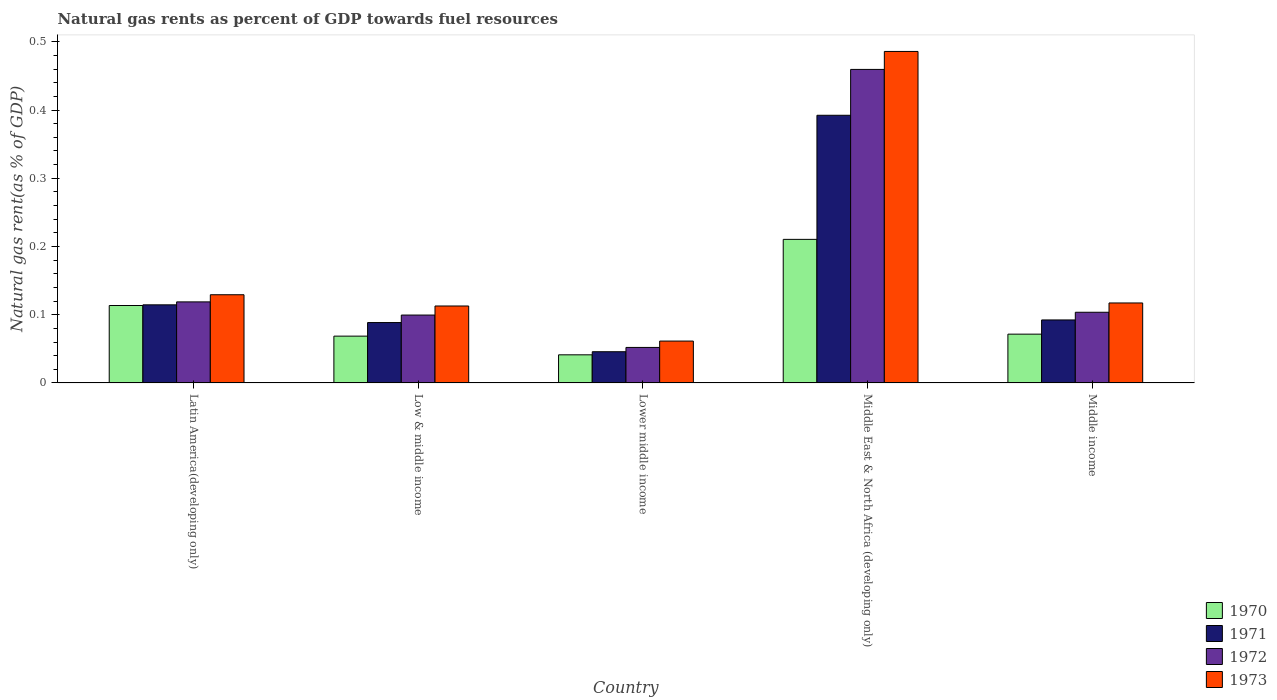How many groups of bars are there?
Your response must be concise. 5. Are the number of bars per tick equal to the number of legend labels?
Give a very brief answer. Yes. Are the number of bars on each tick of the X-axis equal?
Offer a very short reply. Yes. How many bars are there on the 4th tick from the left?
Your response must be concise. 4. What is the label of the 1st group of bars from the left?
Ensure brevity in your answer.  Latin America(developing only). What is the natural gas rent in 1972 in Lower middle income?
Provide a short and direct response. 0.05. Across all countries, what is the maximum natural gas rent in 1973?
Your response must be concise. 0.49. Across all countries, what is the minimum natural gas rent in 1973?
Keep it short and to the point. 0.06. In which country was the natural gas rent in 1972 maximum?
Offer a terse response. Middle East & North Africa (developing only). In which country was the natural gas rent in 1973 minimum?
Provide a short and direct response. Lower middle income. What is the total natural gas rent in 1971 in the graph?
Your answer should be very brief. 0.73. What is the difference between the natural gas rent in 1973 in Lower middle income and that in Middle East & North Africa (developing only)?
Provide a succinct answer. -0.42. What is the difference between the natural gas rent in 1971 in Middle income and the natural gas rent in 1973 in Middle East & North Africa (developing only)?
Give a very brief answer. -0.39. What is the average natural gas rent in 1971 per country?
Ensure brevity in your answer.  0.15. What is the difference between the natural gas rent of/in 1972 and natural gas rent of/in 1973 in Middle income?
Offer a terse response. -0.01. What is the ratio of the natural gas rent in 1973 in Low & middle income to that in Middle East & North Africa (developing only)?
Offer a terse response. 0.23. Is the natural gas rent in 1973 in Low & middle income less than that in Middle income?
Your answer should be compact. Yes. What is the difference between the highest and the second highest natural gas rent in 1971?
Your answer should be compact. 0.3. What is the difference between the highest and the lowest natural gas rent in 1970?
Give a very brief answer. 0.17. In how many countries, is the natural gas rent in 1971 greater than the average natural gas rent in 1971 taken over all countries?
Keep it short and to the point. 1. What does the 1st bar from the left in Middle East & North Africa (developing only) represents?
Keep it short and to the point. 1970. How many bars are there?
Your answer should be very brief. 20. Are all the bars in the graph horizontal?
Your response must be concise. No. How many countries are there in the graph?
Give a very brief answer. 5. Are the values on the major ticks of Y-axis written in scientific E-notation?
Provide a short and direct response. No. Does the graph contain any zero values?
Your answer should be very brief. No. Does the graph contain grids?
Make the answer very short. No. How are the legend labels stacked?
Make the answer very short. Vertical. What is the title of the graph?
Offer a very short reply. Natural gas rents as percent of GDP towards fuel resources. What is the label or title of the Y-axis?
Offer a terse response. Natural gas rent(as % of GDP). What is the Natural gas rent(as % of GDP) in 1970 in Latin America(developing only)?
Ensure brevity in your answer.  0.11. What is the Natural gas rent(as % of GDP) of 1971 in Latin America(developing only)?
Ensure brevity in your answer.  0.11. What is the Natural gas rent(as % of GDP) of 1972 in Latin America(developing only)?
Your response must be concise. 0.12. What is the Natural gas rent(as % of GDP) of 1973 in Latin America(developing only)?
Your answer should be very brief. 0.13. What is the Natural gas rent(as % of GDP) of 1970 in Low & middle income?
Give a very brief answer. 0.07. What is the Natural gas rent(as % of GDP) of 1971 in Low & middle income?
Give a very brief answer. 0.09. What is the Natural gas rent(as % of GDP) of 1972 in Low & middle income?
Your response must be concise. 0.1. What is the Natural gas rent(as % of GDP) of 1973 in Low & middle income?
Make the answer very short. 0.11. What is the Natural gas rent(as % of GDP) in 1970 in Lower middle income?
Give a very brief answer. 0.04. What is the Natural gas rent(as % of GDP) of 1971 in Lower middle income?
Your answer should be compact. 0.05. What is the Natural gas rent(as % of GDP) in 1972 in Lower middle income?
Make the answer very short. 0.05. What is the Natural gas rent(as % of GDP) in 1973 in Lower middle income?
Your response must be concise. 0.06. What is the Natural gas rent(as % of GDP) in 1970 in Middle East & North Africa (developing only)?
Ensure brevity in your answer.  0.21. What is the Natural gas rent(as % of GDP) in 1971 in Middle East & North Africa (developing only)?
Provide a succinct answer. 0.39. What is the Natural gas rent(as % of GDP) in 1972 in Middle East & North Africa (developing only)?
Give a very brief answer. 0.46. What is the Natural gas rent(as % of GDP) of 1973 in Middle East & North Africa (developing only)?
Give a very brief answer. 0.49. What is the Natural gas rent(as % of GDP) of 1970 in Middle income?
Give a very brief answer. 0.07. What is the Natural gas rent(as % of GDP) in 1971 in Middle income?
Your response must be concise. 0.09. What is the Natural gas rent(as % of GDP) in 1972 in Middle income?
Your answer should be very brief. 0.1. What is the Natural gas rent(as % of GDP) of 1973 in Middle income?
Provide a succinct answer. 0.12. Across all countries, what is the maximum Natural gas rent(as % of GDP) in 1970?
Your answer should be very brief. 0.21. Across all countries, what is the maximum Natural gas rent(as % of GDP) in 1971?
Make the answer very short. 0.39. Across all countries, what is the maximum Natural gas rent(as % of GDP) in 1972?
Offer a terse response. 0.46. Across all countries, what is the maximum Natural gas rent(as % of GDP) in 1973?
Give a very brief answer. 0.49. Across all countries, what is the minimum Natural gas rent(as % of GDP) in 1970?
Ensure brevity in your answer.  0.04. Across all countries, what is the minimum Natural gas rent(as % of GDP) in 1971?
Ensure brevity in your answer.  0.05. Across all countries, what is the minimum Natural gas rent(as % of GDP) in 1972?
Your answer should be very brief. 0.05. Across all countries, what is the minimum Natural gas rent(as % of GDP) of 1973?
Make the answer very short. 0.06. What is the total Natural gas rent(as % of GDP) in 1970 in the graph?
Provide a succinct answer. 0.51. What is the total Natural gas rent(as % of GDP) of 1971 in the graph?
Your answer should be very brief. 0.73. What is the total Natural gas rent(as % of GDP) of 1972 in the graph?
Your answer should be compact. 0.83. What is the total Natural gas rent(as % of GDP) of 1973 in the graph?
Your answer should be very brief. 0.91. What is the difference between the Natural gas rent(as % of GDP) of 1970 in Latin America(developing only) and that in Low & middle income?
Your response must be concise. 0.04. What is the difference between the Natural gas rent(as % of GDP) in 1971 in Latin America(developing only) and that in Low & middle income?
Offer a terse response. 0.03. What is the difference between the Natural gas rent(as % of GDP) of 1972 in Latin America(developing only) and that in Low & middle income?
Provide a succinct answer. 0.02. What is the difference between the Natural gas rent(as % of GDP) in 1973 in Latin America(developing only) and that in Low & middle income?
Make the answer very short. 0.02. What is the difference between the Natural gas rent(as % of GDP) of 1970 in Latin America(developing only) and that in Lower middle income?
Give a very brief answer. 0.07. What is the difference between the Natural gas rent(as % of GDP) of 1971 in Latin America(developing only) and that in Lower middle income?
Keep it short and to the point. 0.07. What is the difference between the Natural gas rent(as % of GDP) in 1972 in Latin America(developing only) and that in Lower middle income?
Provide a short and direct response. 0.07. What is the difference between the Natural gas rent(as % of GDP) of 1973 in Latin America(developing only) and that in Lower middle income?
Provide a succinct answer. 0.07. What is the difference between the Natural gas rent(as % of GDP) of 1970 in Latin America(developing only) and that in Middle East & North Africa (developing only)?
Offer a very short reply. -0.1. What is the difference between the Natural gas rent(as % of GDP) of 1971 in Latin America(developing only) and that in Middle East & North Africa (developing only)?
Your answer should be very brief. -0.28. What is the difference between the Natural gas rent(as % of GDP) in 1972 in Latin America(developing only) and that in Middle East & North Africa (developing only)?
Keep it short and to the point. -0.34. What is the difference between the Natural gas rent(as % of GDP) in 1973 in Latin America(developing only) and that in Middle East & North Africa (developing only)?
Give a very brief answer. -0.36. What is the difference between the Natural gas rent(as % of GDP) of 1970 in Latin America(developing only) and that in Middle income?
Offer a very short reply. 0.04. What is the difference between the Natural gas rent(as % of GDP) of 1971 in Latin America(developing only) and that in Middle income?
Keep it short and to the point. 0.02. What is the difference between the Natural gas rent(as % of GDP) of 1972 in Latin America(developing only) and that in Middle income?
Offer a terse response. 0.02. What is the difference between the Natural gas rent(as % of GDP) of 1973 in Latin America(developing only) and that in Middle income?
Provide a short and direct response. 0.01. What is the difference between the Natural gas rent(as % of GDP) of 1970 in Low & middle income and that in Lower middle income?
Ensure brevity in your answer.  0.03. What is the difference between the Natural gas rent(as % of GDP) in 1971 in Low & middle income and that in Lower middle income?
Give a very brief answer. 0.04. What is the difference between the Natural gas rent(as % of GDP) of 1972 in Low & middle income and that in Lower middle income?
Your response must be concise. 0.05. What is the difference between the Natural gas rent(as % of GDP) in 1973 in Low & middle income and that in Lower middle income?
Keep it short and to the point. 0.05. What is the difference between the Natural gas rent(as % of GDP) in 1970 in Low & middle income and that in Middle East & North Africa (developing only)?
Ensure brevity in your answer.  -0.14. What is the difference between the Natural gas rent(as % of GDP) of 1971 in Low & middle income and that in Middle East & North Africa (developing only)?
Provide a succinct answer. -0.3. What is the difference between the Natural gas rent(as % of GDP) in 1972 in Low & middle income and that in Middle East & North Africa (developing only)?
Your answer should be compact. -0.36. What is the difference between the Natural gas rent(as % of GDP) in 1973 in Low & middle income and that in Middle East & North Africa (developing only)?
Offer a terse response. -0.37. What is the difference between the Natural gas rent(as % of GDP) of 1970 in Low & middle income and that in Middle income?
Offer a terse response. -0. What is the difference between the Natural gas rent(as % of GDP) of 1971 in Low & middle income and that in Middle income?
Provide a succinct answer. -0. What is the difference between the Natural gas rent(as % of GDP) in 1972 in Low & middle income and that in Middle income?
Offer a very short reply. -0. What is the difference between the Natural gas rent(as % of GDP) in 1973 in Low & middle income and that in Middle income?
Ensure brevity in your answer.  -0. What is the difference between the Natural gas rent(as % of GDP) in 1970 in Lower middle income and that in Middle East & North Africa (developing only)?
Your answer should be very brief. -0.17. What is the difference between the Natural gas rent(as % of GDP) in 1971 in Lower middle income and that in Middle East & North Africa (developing only)?
Keep it short and to the point. -0.35. What is the difference between the Natural gas rent(as % of GDP) of 1972 in Lower middle income and that in Middle East & North Africa (developing only)?
Provide a succinct answer. -0.41. What is the difference between the Natural gas rent(as % of GDP) of 1973 in Lower middle income and that in Middle East & North Africa (developing only)?
Your answer should be very brief. -0.42. What is the difference between the Natural gas rent(as % of GDP) in 1970 in Lower middle income and that in Middle income?
Keep it short and to the point. -0.03. What is the difference between the Natural gas rent(as % of GDP) of 1971 in Lower middle income and that in Middle income?
Offer a terse response. -0.05. What is the difference between the Natural gas rent(as % of GDP) in 1972 in Lower middle income and that in Middle income?
Ensure brevity in your answer.  -0.05. What is the difference between the Natural gas rent(as % of GDP) in 1973 in Lower middle income and that in Middle income?
Keep it short and to the point. -0.06. What is the difference between the Natural gas rent(as % of GDP) in 1970 in Middle East & North Africa (developing only) and that in Middle income?
Provide a short and direct response. 0.14. What is the difference between the Natural gas rent(as % of GDP) in 1971 in Middle East & North Africa (developing only) and that in Middle income?
Provide a short and direct response. 0.3. What is the difference between the Natural gas rent(as % of GDP) in 1972 in Middle East & North Africa (developing only) and that in Middle income?
Make the answer very short. 0.36. What is the difference between the Natural gas rent(as % of GDP) of 1973 in Middle East & North Africa (developing only) and that in Middle income?
Your answer should be compact. 0.37. What is the difference between the Natural gas rent(as % of GDP) in 1970 in Latin America(developing only) and the Natural gas rent(as % of GDP) in 1971 in Low & middle income?
Provide a short and direct response. 0.03. What is the difference between the Natural gas rent(as % of GDP) in 1970 in Latin America(developing only) and the Natural gas rent(as % of GDP) in 1972 in Low & middle income?
Provide a short and direct response. 0.01. What is the difference between the Natural gas rent(as % of GDP) of 1970 in Latin America(developing only) and the Natural gas rent(as % of GDP) of 1973 in Low & middle income?
Your response must be concise. 0. What is the difference between the Natural gas rent(as % of GDP) in 1971 in Latin America(developing only) and the Natural gas rent(as % of GDP) in 1972 in Low & middle income?
Your response must be concise. 0.01. What is the difference between the Natural gas rent(as % of GDP) of 1971 in Latin America(developing only) and the Natural gas rent(as % of GDP) of 1973 in Low & middle income?
Make the answer very short. 0. What is the difference between the Natural gas rent(as % of GDP) in 1972 in Latin America(developing only) and the Natural gas rent(as % of GDP) in 1973 in Low & middle income?
Your response must be concise. 0.01. What is the difference between the Natural gas rent(as % of GDP) in 1970 in Latin America(developing only) and the Natural gas rent(as % of GDP) in 1971 in Lower middle income?
Offer a very short reply. 0.07. What is the difference between the Natural gas rent(as % of GDP) in 1970 in Latin America(developing only) and the Natural gas rent(as % of GDP) in 1972 in Lower middle income?
Keep it short and to the point. 0.06. What is the difference between the Natural gas rent(as % of GDP) in 1970 in Latin America(developing only) and the Natural gas rent(as % of GDP) in 1973 in Lower middle income?
Offer a terse response. 0.05. What is the difference between the Natural gas rent(as % of GDP) in 1971 in Latin America(developing only) and the Natural gas rent(as % of GDP) in 1972 in Lower middle income?
Your answer should be very brief. 0.06. What is the difference between the Natural gas rent(as % of GDP) of 1971 in Latin America(developing only) and the Natural gas rent(as % of GDP) of 1973 in Lower middle income?
Your answer should be compact. 0.05. What is the difference between the Natural gas rent(as % of GDP) of 1972 in Latin America(developing only) and the Natural gas rent(as % of GDP) of 1973 in Lower middle income?
Ensure brevity in your answer.  0.06. What is the difference between the Natural gas rent(as % of GDP) in 1970 in Latin America(developing only) and the Natural gas rent(as % of GDP) in 1971 in Middle East & North Africa (developing only)?
Ensure brevity in your answer.  -0.28. What is the difference between the Natural gas rent(as % of GDP) of 1970 in Latin America(developing only) and the Natural gas rent(as % of GDP) of 1972 in Middle East & North Africa (developing only)?
Ensure brevity in your answer.  -0.35. What is the difference between the Natural gas rent(as % of GDP) in 1970 in Latin America(developing only) and the Natural gas rent(as % of GDP) in 1973 in Middle East & North Africa (developing only)?
Your response must be concise. -0.37. What is the difference between the Natural gas rent(as % of GDP) of 1971 in Latin America(developing only) and the Natural gas rent(as % of GDP) of 1972 in Middle East & North Africa (developing only)?
Your response must be concise. -0.35. What is the difference between the Natural gas rent(as % of GDP) of 1971 in Latin America(developing only) and the Natural gas rent(as % of GDP) of 1973 in Middle East & North Africa (developing only)?
Offer a very short reply. -0.37. What is the difference between the Natural gas rent(as % of GDP) of 1972 in Latin America(developing only) and the Natural gas rent(as % of GDP) of 1973 in Middle East & North Africa (developing only)?
Provide a short and direct response. -0.37. What is the difference between the Natural gas rent(as % of GDP) of 1970 in Latin America(developing only) and the Natural gas rent(as % of GDP) of 1971 in Middle income?
Ensure brevity in your answer.  0.02. What is the difference between the Natural gas rent(as % of GDP) of 1970 in Latin America(developing only) and the Natural gas rent(as % of GDP) of 1972 in Middle income?
Offer a very short reply. 0.01. What is the difference between the Natural gas rent(as % of GDP) of 1970 in Latin America(developing only) and the Natural gas rent(as % of GDP) of 1973 in Middle income?
Offer a terse response. -0. What is the difference between the Natural gas rent(as % of GDP) of 1971 in Latin America(developing only) and the Natural gas rent(as % of GDP) of 1972 in Middle income?
Offer a terse response. 0.01. What is the difference between the Natural gas rent(as % of GDP) in 1971 in Latin America(developing only) and the Natural gas rent(as % of GDP) in 1973 in Middle income?
Give a very brief answer. -0. What is the difference between the Natural gas rent(as % of GDP) of 1972 in Latin America(developing only) and the Natural gas rent(as % of GDP) of 1973 in Middle income?
Provide a succinct answer. 0. What is the difference between the Natural gas rent(as % of GDP) in 1970 in Low & middle income and the Natural gas rent(as % of GDP) in 1971 in Lower middle income?
Your answer should be compact. 0.02. What is the difference between the Natural gas rent(as % of GDP) of 1970 in Low & middle income and the Natural gas rent(as % of GDP) of 1972 in Lower middle income?
Provide a short and direct response. 0.02. What is the difference between the Natural gas rent(as % of GDP) in 1970 in Low & middle income and the Natural gas rent(as % of GDP) in 1973 in Lower middle income?
Make the answer very short. 0.01. What is the difference between the Natural gas rent(as % of GDP) in 1971 in Low & middle income and the Natural gas rent(as % of GDP) in 1972 in Lower middle income?
Keep it short and to the point. 0.04. What is the difference between the Natural gas rent(as % of GDP) in 1971 in Low & middle income and the Natural gas rent(as % of GDP) in 1973 in Lower middle income?
Ensure brevity in your answer.  0.03. What is the difference between the Natural gas rent(as % of GDP) in 1972 in Low & middle income and the Natural gas rent(as % of GDP) in 1973 in Lower middle income?
Provide a short and direct response. 0.04. What is the difference between the Natural gas rent(as % of GDP) in 1970 in Low & middle income and the Natural gas rent(as % of GDP) in 1971 in Middle East & North Africa (developing only)?
Make the answer very short. -0.32. What is the difference between the Natural gas rent(as % of GDP) of 1970 in Low & middle income and the Natural gas rent(as % of GDP) of 1972 in Middle East & North Africa (developing only)?
Your response must be concise. -0.39. What is the difference between the Natural gas rent(as % of GDP) of 1970 in Low & middle income and the Natural gas rent(as % of GDP) of 1973 in Middle East & North Africa (developing only)?
Give a very brief answer. -0.42. What is the difference between the Natural gas rent(as % of GDP) of 1971 in Low & middle income and the Natural gas rent(as % of GDP) of 1972 in Middle East & North Africa (developing only)?
Provide a short and direct response. -0.37. What is the difference between the Natural gas rent(as % of GDP) of 1971 in Low & middle income and the Natural gas rent(as % of GDP) of 1973 in Middle East & North Africa (developing only)?
Offer a terse response. -0.4. What is the difference between the Natural gas rent(as % of GDP) of 1972 in Low & middle income and the Natural gas rent(as % of GDP) of 1973 in Middle East & North Africa (developing only)?
Ensure brevity in your answer.  -0.39. What is the difference between the Natural gas rent(as % of GDP) of 1970 in Low & middle income and the Natural gas rent(as % of GDP) of 1971 in Middle income?
Keep it short and to the point. -0.02. What is the difference between the Natural gas rent(as % of GDP) of 1970 in Low & middle income and the Natural gas rent(as % of GDP) of 1972 in Middle income?
Provide a short and direct response. -0.04. What is the difference between the Natural gas rent(as % of GDP) of 1970 in Low & middle income and the Natural gas rent(as % of GDP) of 1973 in Middle income?
Offer a terse response. -0.05. What is the difference between the Natural gas rent(as % of GDP) of 1971 in Low & middle income and the Natural gas rent(as % of GDP) of 1972 in Middle income?
Your answer should be compact. -0.02. What is the difference between the Natural gas rent(as % of GDP) in 1971 in Low & middle income and the Natural gas rent(as % of GDP) in 1973 in Middle income?
Offer a terse response. -0.03. What is the difference between the Natural gas rent(as % of GDP) of 1972 in Low & middle income and the Natural gas rent(as % of GDP) of 1973 in Middle income?
Provide a succinct answer. -0.02. What is the difference between the Natural gas rent(as % of GDP) of 1970 in Lower middle income and the Natural gas rent(as % of GDP) of 1971 in Middle East & North Africa (developing only)?
Offer a very short reply. -0.35. What is the difference between the Natural gas rent(as % of GDP) of 1970 in Lower middle income and the Natural gas rent(as % of GDP) of 1972 in Middle East & North Africa (developing only)?
Provide a short and direct response. -0.42. What is the difference between the Natural gas rent(as % of GDP) of 1970 in Lower middle income and the Natural gas rent(as % of GDP) of 1973 in Middle East & North Africa (developing only)?
Offer a very short reply. -0.44. What is the difference between the Natural gas rent(as % of GDP) in 1971 in Lower middle income and the Natural gas rent(as % of GDP) in 1972 in Middle East & North Africa (developing only)?
Offer a very short reply. -0.41. What is the difference between the Natural gas rent(as % of GDP) of 1971 in Lower middle income and the Natural gas rent(as % of GDP) of 1973 in Middle East & North Africa (developing only)?
Provide a succinct answer. -0.44. What is the difference between the Natural gas rent(as % of GDP) in 1972 in Lower middle income and the Natural gas rent(as % of GDP) in 1973 in Middle East & North Africa (developing only)?
Your answer should be compact. -0.43. What is the difference between the Natural gas rent(as % of GDP) of 1970 in Lower middle income and the Natural gas rent(as % of GDP) of 1971 in Middle income?
Offer a very short reply. -0.05. What is the difference between the Natural gas rent(as % of GDP) in 1970 in Lower middle income and the Natural gas rent(as % of GDP) in 1972 in Middle income?
Provide a succinct answer. -0.06. What is the difference between the Natural gas rent(as % of GDP) in 1970 in Lower middle income and the Natural gas rent(as % of GDP) in 1973 in Middle income?
Make the answer very short. -0.08. What is the difference between the Natural gas rent(as % of GDP) in 1971 in Lower middle income and the Natural gas rent(as % of GDP) in 1972 in Middle income?
Provide a succinct answer. -0.06. What is the difference between the Natural gas rent(as % of GDP) in 1971 in Lower middle income and the Natural gas rent(as % of GDP) in 1973 in Middle income?
Keep it short and to the point. -0.07. What is the difference between the Natural gas rent(as % of GDP) of 1972 in Lower middle income and the Natural gas rent(as % of GDP) of 1973 in Middle income?
Your response must be concise. -0.07. What is the difference between the Natural gas rent(as % of GDP) in 1970 in Middle East & North Africa (developing only) and the Natural gas rent(as % of GDP) in 1971 in Middle income?
Offer a very short reply. 0.12. What is the difference between the Natural gas rent(as % of GDP) of 1970 in Middle East & North Africa (developing only) and the Natural gas rent(as % of GDP) of 1972 in Middle income?
Provide a succinct answer. 0.11. What is the difference between the Natural gas rent(as % of GDP) in 1970 in Middle East & North Africa (developing only) and the Natural gas rent(as % of GDP) in 1973 in Middle income?
Give a very brief answer. 0.09. What is the difference between the Natural gas rent(as % of GDP) of 1971 in Middle East & North Africa (developing only) and the Natural gas rent(as % of GDP) of 1972 in Middle income?
Keep it short and to the point. 0.29. What is the difference between the Natural gas rent(as % of GDP) in 1971 in Middle East & North Africa (developing only) and the Natural gas rent(as % of GDP) in 1973 in Middle income?
Offer a very short reply. 0.28. What is the difference between the Natural gas rent(as % of GDP) of 1972 in Middle East & North Africa (developing only) and the Natural gas rent(as % of GDP) of 1973 in Middle income?
Your answer should be very brief. 0.34. What is the average Natural gas rent(as % of GDP) in 1970 per country?
Your answer should be compact. 0.1. What is the average Natural gas rent(as % of GDP) of 1971 per country?
Provide a succinct answer. 0.15. What is the average Natural gas rent(as % of GDP) of 1973 per country?
Your answer should be compact. 0.18. What is the difference between the Natural gas rent(as % of GDP) in 1970 and Natural gas rent(as % of GDP) in 1971 in Latin America(developing only)?
Offer a terse response. -0. What is the difference between the Natural gas rent(as % of GDP) of 1970 and Natural gas rent(as % of GDP) of 1972 in Latin America(developing only)?
Your answer should be very brief. -0.01. What is the difference between the Natural gas rent(as % of GDP) of 1970 and Natural gas rent(as % of GDP) of 1973 in Latin America(developing only)?
Make the answer very short. -0.02. What is the difference between the Natural gas rent(as % of GDP) in 1971 and Natural gas rent(as % of GDP) in 1972 in Latin America(developing only)?
Offer a terse response. -0. What is the difference between the Natural gas rent(as % of GDP) in 1971 and Natural gas rent(as % of GDP) in 1973 in Latin America(developing only)?
Provide a short and direct response. -0.01. What is the difference between the Natural gas rent(as % of GDP) in 1972 and Natural gas rent(as % of GDP) in 1973 in Latin America(developing only)?
Make the answer very short. -0.01. What is the difference between the Natural gas rent(as % of GDP) of 1970 and Natural gas rent(as % of GDP) of 1971 in Low & middle income?
Provide a short and direct response. -0.02. What is the difference between the Natural gas rent(as % of GDP) in 1970 and Natural gas rent(as % of GDP) in 1972 in Low & middle income?
Provide a short and direct response. -0.03. What is the difference between the Natural gas rent(as % of GDP) of 1970 and Natural gas rent(as % of GDP) of 1973 in Low & middle income?
Your answer should be compact. -0.04. What is the difference between the Natural gas rent(as % of GDP) of 1971 and Natural gas rent(as % of GDP) of 1972 in Low & middle income?
Your response must be concise. -0.01. What is the difference between the Natural gas rent(as % of GDP) of 1971 and Natural gas rent(as % of GDP) of 1973 in Low & middle income?
Give a very brief answer. -0.02. What is the difference between the Natural gas rent(as % of GDP) in 1972 and Natural gas rent(as % of GDP) in 1973 in Low & middle income?
Ensure brevity in your answer.  -0.01. What is the difference between the Natural gas rent(as % of GDP) of 1970 and Natural gas rent(as % of GDP) of 1971 in Lower middle income?
Provide a succinct answer. -0. What is the difference between the Natural gas rent(as % of GDP) in 1970 and Natural gas rent(as % of GDP) in 1972 in Lower middle income?
Your response must be concise. -0.01. What is the difference between the Natural gas rent(as % of GDP) in 1970 and Natural gas rent(as % of GDP) in 1973 in Lower middle income?
Keep it short and to the point. -0.02. What is the difference between the Natural gas rent(as % of GDP) in 1971 and Natural gas rent(as % of GDP) in 1972 in Lower middle income?
Your answer should be very brief. -0.01. What is the difference between the Natural gas rent(as % of GDP) in 1971 and Natural gas rent(as % of GDP) in 1973 in Lower middle income?
Offer a very short reply. -0.02. What is the difference between the Natural gas rent(as % of GDP) of 1972 and Natural gas rent(as % of GDP) of 1973 in Lower middle income?
Keep it short and to the point. -0.01. What is the difference between the Natural gas rent(as % of GDP) in 1970 and Natural gas rent(as % of GDP) in 1971 in Middle East & North Africa (developing only)?
Your answer should be compact. -0.18. What is the difference between the Natural gas rent(as % of GDP) of 1970 and Natural gas rent(as % of GDP) of 1972 in Middle East & North Africa (developing only)?
Give a very brief answer. -0.25. What is the difference between the Natural gas rent(as % of GDP) of 1970 and Natural gas rent(as % of GDP) of 1973 in Middle East & North Africa (developing only)?
Offer a terse response. -0.28. What is the difference between the Natural gas rent(as % of GDP) of 1971 and Natural gas rent(as % of GDP) of 1972 in Middle East & North Africa (developing only)?
Ensure brevity in your answer.  -0.07. What is the difference between the Natural gas rent(as % of GDP) of 1971 and Natural gas rent(as % of GDP) of 1973 in Middle East & North Africa (developing only)?
Make the answer very short. -0.09. What is the difference between the Natural gas rent(as % of GDP) of 1972 and Natural gas rent(as % of GDP) of 1973 in Middle East & North Africa (developing only)?
Your answer should be very brief. -0.03. What is the difference between the Natural gas rent(as % of GDP) in 1970 and Natural gas rent(as % of GDP) in 1971 in Middle income?
Your response must be concise. -0.02. What is the difference between the Natural gas rent(as % of GDP) of 1970 and Natural gas rent(as % of GDP) of 1972 in Middle income?
Ensure brevity in your answer.  -0.03. What is the difference between the Natural gas rent(as % of GDP) of 1970 and Natural gas rent(as % of GDP) of 1973 in Middle income?
Offer a terse response. -0.05. What is the difference between the Natural gas rent(as % of GDP) of 1971 and Natural gas rent(as % of GDP) of 1972 in Middle income?
Make the answer very short. -0.01. What is the difference between the Natural gas rent(as % of GDP) of 1971 and Natural gas rent(as % of GDP) of 1973 in Middle income?
Your answer should be compact. -0.02. What is the difference between the Natural gas rent(as % of GDP) of 1972 and Natural gas rent(as % of GDP) of 1973 in Middle income?
Make the answer very short. -0.01. What is the ratio of the Natural gas rent(as % of GDP) of 1970 in Latin America(developing only) to that in Low & middle income?
Your answer should be compact. 1.65. What is the ratio of the Natural gas rent(as % of GDP) of 1971 in Latin America(developing only) to that in Low & middle income?
Offer a very short reply. 1.29. What is the ratio of the Natural gas rent(as % of GDP) in 1972 in Latin America(developing only) to that in Low & middle income?
Provide a succinct answer. 1.19. What is the ratio of the Natural gas rent(as % of GDP) of 1973 in Latin America(developing only) to that in Low & middle income?
Your response must be concise. 1.15. What is the ratio of the Natural gas rent(as % of GDP) of 1970 in Latin America(developing only) to that in Lower middle income?
Ensure brevity in your answer.  2.75. What is the ratio of the Natural gas rent(as % of GDP) in 1971 in Latin America(developing only) to that in Lower middle income?
Keep it short and to the point. 2.5. What is the ratio of the Natural gas rent(as % of GDP) in 1972 in Latin America(developing only) to that in Lower middle income?
Make the answer very short. 2.28. What is the ratio of the Natural gas rent(as % of GDP) in 1973 in Latin America(developing only) to that in Lower middle income?
Offer a very short reply. 2.11. What is the ratio of the Natural gas rent(as % of GDP) of 1970 in Latin America(developing only) to that in Middle East & North Africa (developing only)?
Your answer should be compact. 0.54. What is the ratio of the Natural gas rent(as % of GDP) in 1971 in Latin America(developing only) to that in Middle East & North Africa (developing only)?
Provide a succinct answer. 0.29. What is the ratio of the Natural gas rent(as % of GDP) of 1972 in Latin America(developing only) to that in Middle East & North Africa (developing only)?
Keep it short and to the point. 0.26. What is the ratio of the Natural gas rent(as % of GDP) in 1973 in Latin America(developing only) to that in Middle East & North Africa (developing only)?
Offer a terse response. 0.27. What is the ratio of the Natural gas rent(as % of GDP) in 1970 in Latin America(developing only) to that in Middle income?
Provide a short and direct response. 1.59. What is the ratio of the Natural gas rent(as % of GDP) of 1971 in Latin America(developing only) to that in Middle income?
Provide a short and direct response. 1.24. What is the ratio of the Natural gas rent(as % of GDP) of 1972 in Latin America(developing only) to that in Middle income?
Provide a short and direct response. 1.15. What is the ratio of the Natural gas rent(as % of GDP) of 1973 in Latin America(developing only) to that in Middle income?
Provide a short and direct response. 1.1. What is the ratio of the Natural gas rent(as % of GDP) in 1970 in Low & middle income to that in Lower middle income?
Make the answer very short. 1.66. What is the ratio of the Natural gas rent(as % of GDP) of 1971 in Low & middle income to that in Lower middle income?
Provide a short and direct response. 1.93. What is the ratio of the Natural gas rent(as % of GDP) of 1972 in Low & middle income to that in Lower middle income?
Provide a short and direct response. 1.91. What is the ratio of the Natural gas rent(as % of GDP) in 1973 in Low & middle income to that in Lower middle income?
Ensure brevity in your answer.  1.84. What is the ratio of the Natural gas rent(as % of GDP) of 1970 in Low & middle income to that in Middle East & North Africa (developing only)?
Offer a very short reply. 0.33. What is the ratio of the Natural gas rent(as % of GDP) of 1971 in Low & middle income to that in Middle East & North Africa (developing only)?
Provide a succinct answer. 0.23. What is the ratio of the Natural gas rent(as % of GDP) of 1972 in Low & middle income to that in Middle East & North Africa (developing only)?
Ensure brevity in your answer.  0.22. What is the ratio of the Natural gas rent(as % of GDP) in 1973 in Low & middle income to that in Middle East & North Africa (developing only)?
Ensure brevity in your answer.  0.23. What is the ratio of the Natural gas rent(as % of GDP) of 1970 in Low & middle income to that in Middle income?
Offer a terse response. 0.96. What is the ratio of the Natural gas rent(as % of GDP) in 1971 in Low & middle income to that in Middle income?
Give a very brief answer. 0.96. What is the ratio of the Natural gas rent(as % of GDP) in 1972 in Low & middle income to that in Middle income?
Your response must be concise. 0.96. What is the ratio of the Natural gas rent(as % of GDP) of 1973 in Low & middle income to that in Middle income?
Your answer should be very brief. 0.96. What is the ratio of the Natural gas rent(as % of GDP) of 1970 in Lower middle income to that in Middle East & North Africa (developing only)?
Offer a terse response. 0.2. What is the ratio of the Natural gas rent(as % of GDP) of 1971 in Lower middle income to that in Middle East & North Africa (developing only)?
Keep it short and to the point. 0.12. What is the ratio of the Natural gas rent(as % of GDP) in 1972 in Lower middle income to that in Middle East & North Africa (developing only)?
Give a very brief answer. 0.11. What is the ratio of the Natural gas rent(as % of GDP) of 1973 in Lower middle income to that in Middle East & North Africa (developing only)?
Provide a short and direct response. 0.13. What is the ratio of the Natural gas rent(as % of GDP) in 1970 in Lower middle income to that in Middle income?
Give a very brief answer. 0.58. What is the ratio of the Natural gas rent(as % of GDP) of 1971 in Lower middle income to that in Middle income?
Your answer should be compact. 0.5. What is the ratio of the Natural gas rent(as % of GDP) of 1972 in Lower middle income to that in Middle income?
Provide a short and direct response. 0.5. What is the ratio of the Natural gas rent(as % of GDP) of 1973 in Lower middle income to that in Middle income?
Provide a short and direct response. 0.52. What is the ratio of the Natural gas rent(as % of GDP) of 1970 in Middle East & North Africa (developing only) to that in Middle income?
Your response must be concise. 2.94. What is the ratio of the Natural gas rent(as % of GDP) in 1971 in Middle East & North Africa (developing only) to that in Middle income?
Make the answer very short. 4.25. What is the ratio of the Natural gas rent(as % of GDP) of 1972 in Middle East & North Africa (developing only) to that in Middle income?
Provide a succinct answer. 4.44. What is the ratio of the Natural gas rent(as % of GDP) in 1973 in Middle East & North Africa (developing only) to that in Middle income?
Offer a terse response. 4.14. What is the difference between the highest and the second highest Natural gas rent(as % of GDP) of 1970?
Provide a succinct answer. 0.1. What is the difference between the highest and the second highest Natural gas rent(as % of GDP) of 1971?
Provide a short and direct response. 0.28. What is the difference between the highest and the second highest Natural gas rent(as % of GDP) of 1972?
Your response must be concise. 0.34. What is the difference between the highest and the second highest Natural gas rent(as % of GDP) in 1973?
Make the answer very short. 0.36. What is the difference between the highest and the lowest Natural gas rent(as % of GDP) of 1970?
Provide a short and direct response. 0.17. What is the difference between the highest and the lowest Natural gas rent(as % of GDP) in 1971?
Give a very brief answer. 0.35. What is the difference between the highest and the lowest Natural gas rent(as % of GDP) of 1972?
Your answer should be compact. 0.41. What is the difference between the highest and the lowest Natural gas rent(as % of GDP) in 1973?
Ensure brevity in your answer.  0.42. 